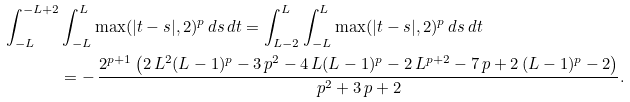Convert formula to latex. <formula><loc_0><loc_0><loc_500><loc_500>\int _ { - L } ^ { - L + 2 } & \int _ { - L } ^ { L } \max ( | t - s | , 2 ) ^ { p } \, d s \, d t = \int _ { L - 2 } ^ { L } \int _ { - L } ^ { L } \max ( | t - s | , 2 ) ^ { p } \, d s \, d t \\ & = - \, { \frac { 2 ^ { p + 1 } \left ( 2 \, { L } ^ { 2 } ( L - 1 ) ^ { p } - 3 \, { p } ^ { 2 } - 4 \, L ( L - 1 ) ^ { p } - { 2 } \, { L } ^ { p + 2 } - 7 \, p + 2 \, ( L - 1 ) ^ { p } - 2 \right ) } { { p } ^ { 2 } + 3 \, p + 2 } } .</formula> 